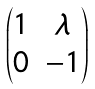Convert formula to latex. <formula><loc_0><loc_0><loc_500><loc_500>\begin{pmatrix} 1 & \lambda \\ 0 & - 1 \end{pmatrix}</formula> 